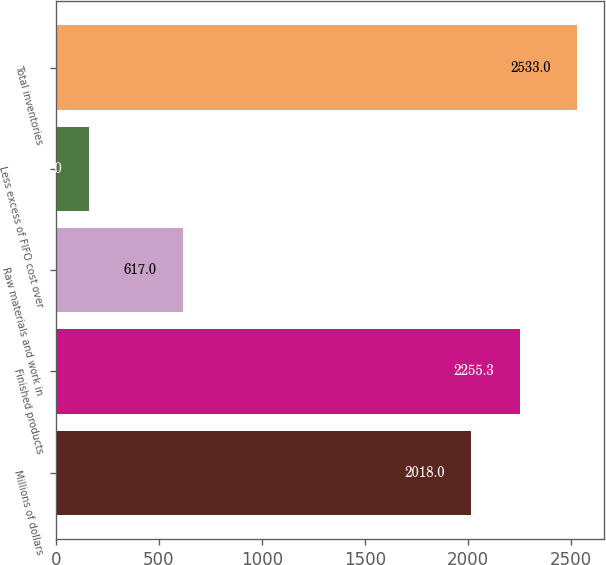<chart> <loc_0><loc_0><loc_500><loc_500><bar_chart><fcel>Millions of dollars<fcel>Finished products<fcel>Raw materials and work in<fcel>Less excess of FIFO cost over<fcel>Total inventories<nl><fcel>2018<fcel>2255.3<fcel>617<fcel>160<fcel>2533<nl></chart> 